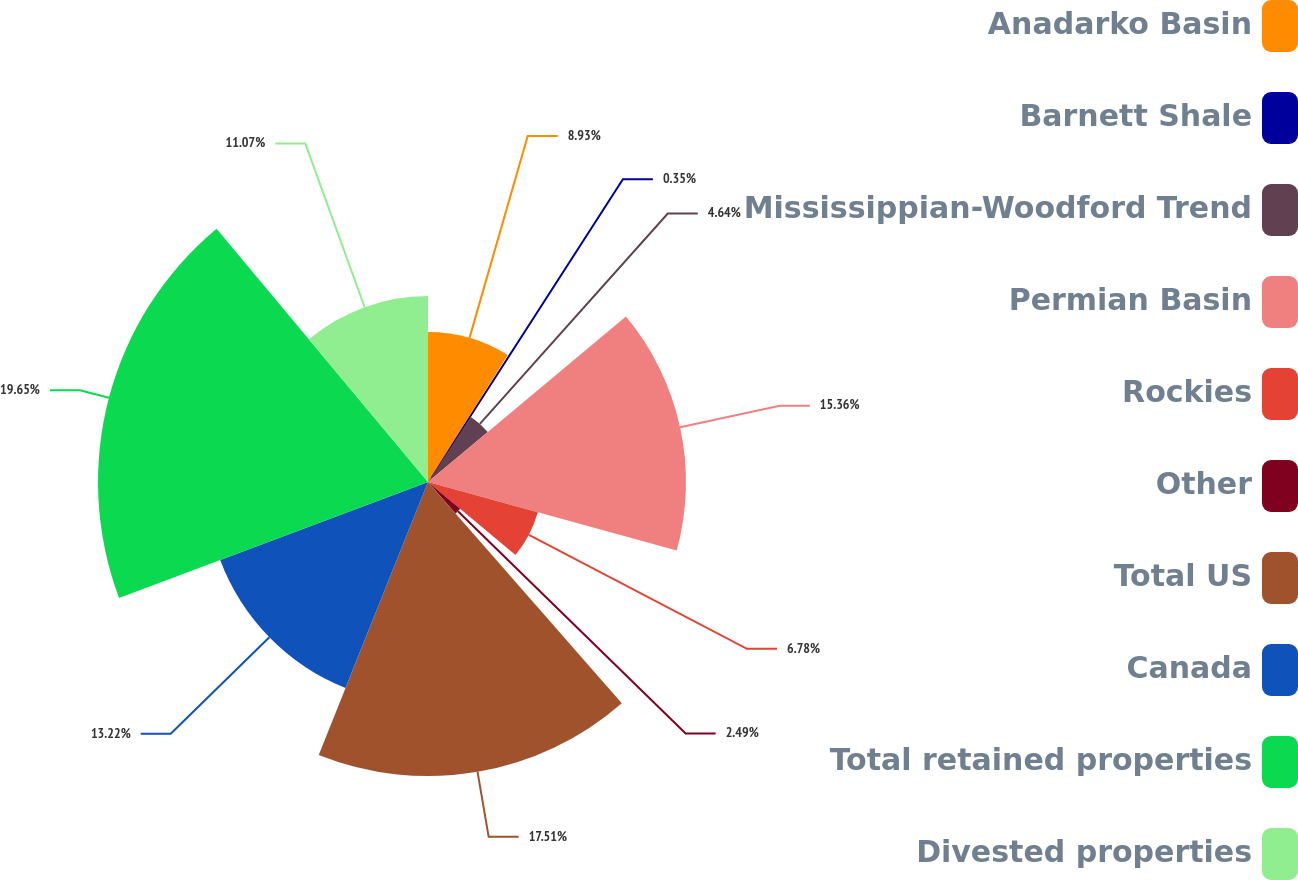<chart> <loc_0><loc_0><loc_500><loc_500><pie_chart><fcel>Anadarko Basin<fcel>Barnett Shale<fcel>Mississippian-Woodford Trend<fcel>Permian Basin<fcel>Rockies<fcel>Other<fcel>Total US<fcel>Canada<fcel>Total retained properties<fcel>Divested properties<nl><fcel>8.93%<fcel>0.35%<fcel>4.64%<fcel>15.36%<fcel>6.78%<fcel>2.49%<fcel>17.51%<fcel>13.22%<fcel>19.65%<fcel>11.07%<nl></chart> 